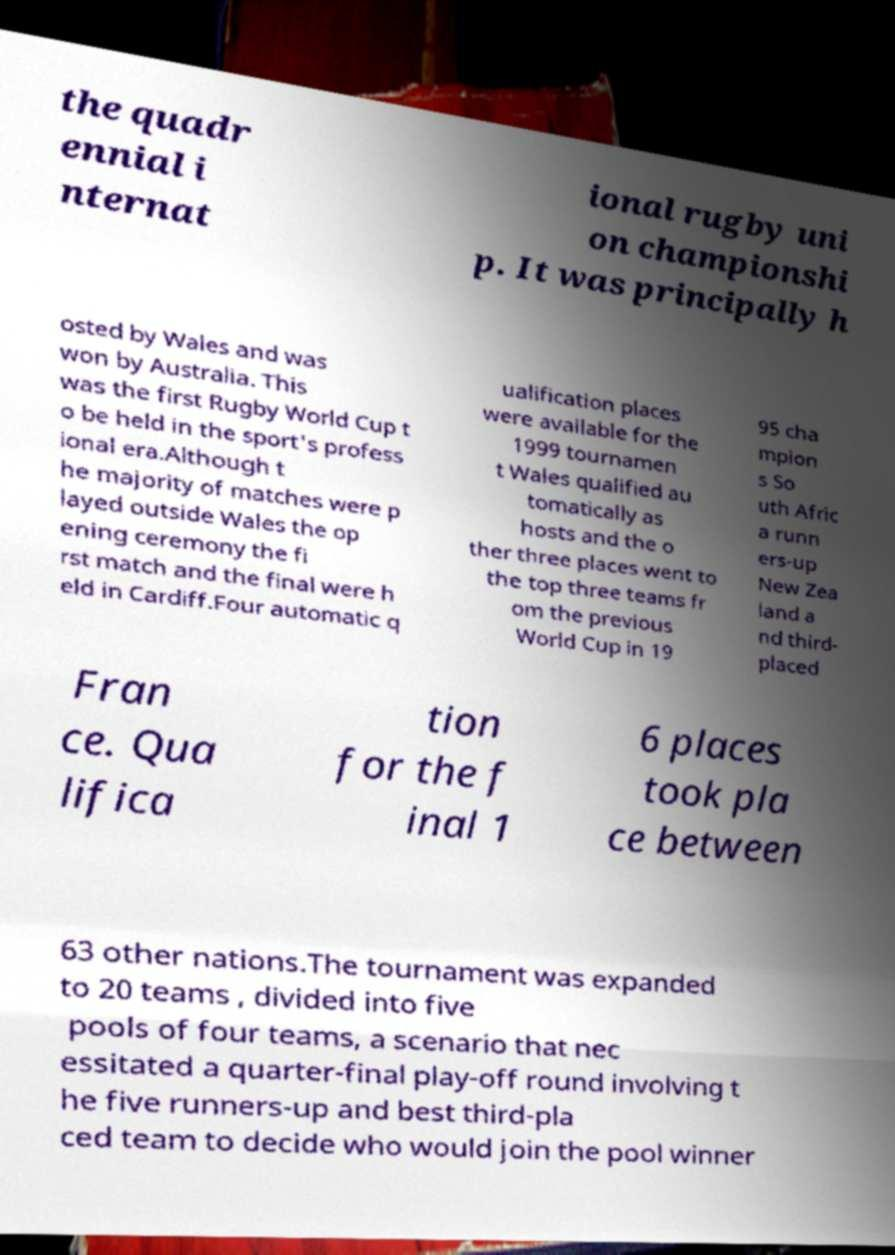I need the written content from this picture converted into text. Can you do that? the quadr ennial i nternat ional rugby uni on championshi p. It was principally h osted by Wales and was won by Australia. This was the first Rugby World Cup t o be held in the sport's profess ional era.Although t he majority of matches were p layed outside Wales the op ening ceremony the fi rst match and the final were h eld in Cardiff.Four automatic q ualification places were available for the 1999 tournamen t Wales qualified au tomatically as hosts and the o ther three places went to the top three teams fr om the previous World Cup in 19 95 cha mpion s So uth Afric a runn ers-up New Zea land a nd third- placed Fran ce. Qua lifica tion for the f inal 1 6 places took pla ce between 63 other nations.The tournament was expanded to 20 teams , divided into five pools of four teams, a scenario that nec essitated a quarter-final play-off round involving t he five runners-up and best third-pla ced team to decide who would join the pool winner 